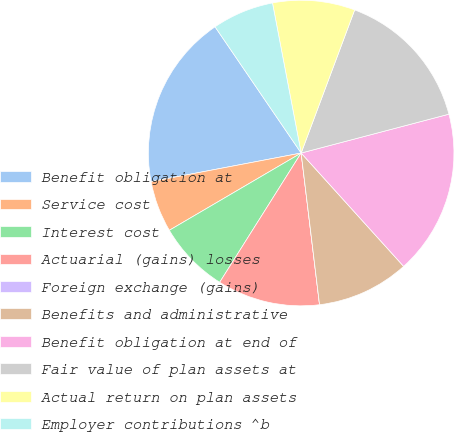Convert chart. <chart><loc_0><loc_0><loc_500><loc_500><pie_chart><fcel>Benefit obligation at<fcel>Service cost<fcel>Interest cost<fcel>Actuarial (gains) losses<fcel>Foreign exchange (gains)<fcel>Benefits and administrative<fcel>Benefit obligation at end of<fcel>Fair value of plan assets at<fcel>Actual return on plan assets<fcel>Employer contributions ^b<nl><fcel>18.47%<fcel>5.44%<fcel>7.61%<fcel>10.87%<fcel>0.0%<fcel>9.78%<fcel>17.39%<fcel>15.21%<fcel>8.7%<fcel>6.52%<nl></chart> 